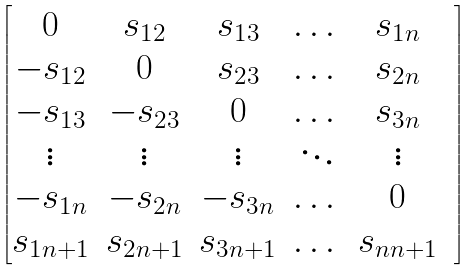Convert formula to latex. <formula><loc_0><loc_0><loc_500><loc_500>\begin{bmatrix} 0 & s _ { 1 2 } & s _ { 1 3 } & \dots & s _ { 1 n } & \\ - s _ { 1 2 } & 0 & s _ { 2 3 } & \dots & s _ { 2 n } & \\ - s _ { 1 3 } & - s _ { 2 3 } & 0 & \dots & s _ { 3 n } & \\ \vdots & \vdots & \vdots & \ddots & \vdots & \\ - s _ { 1 n } & - s _ { 2 n } & - s _ { 3 n } & \dots & 0 & \\ s _ { 1 n + 1 } & s _ { 2 n + 1 } & s _ { 3 n + 1 } & \dots & s _ { n n + 1 } & \\ \end{bmatrix}</formula> 